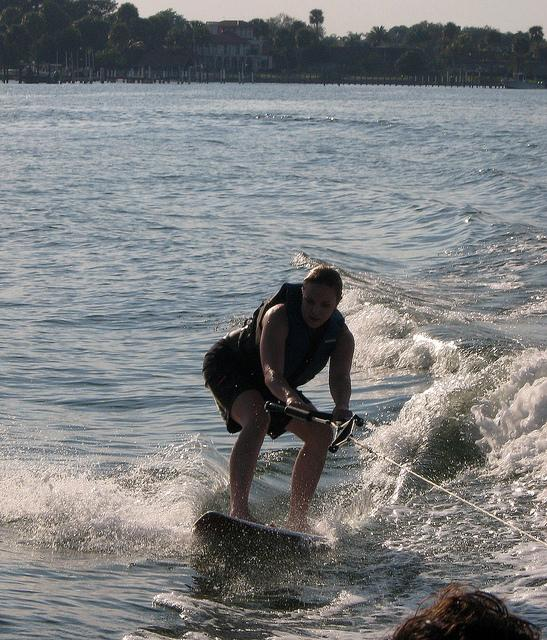What form of exercise is this? Please explain your reasoning. water skiing. This is water skiing. 